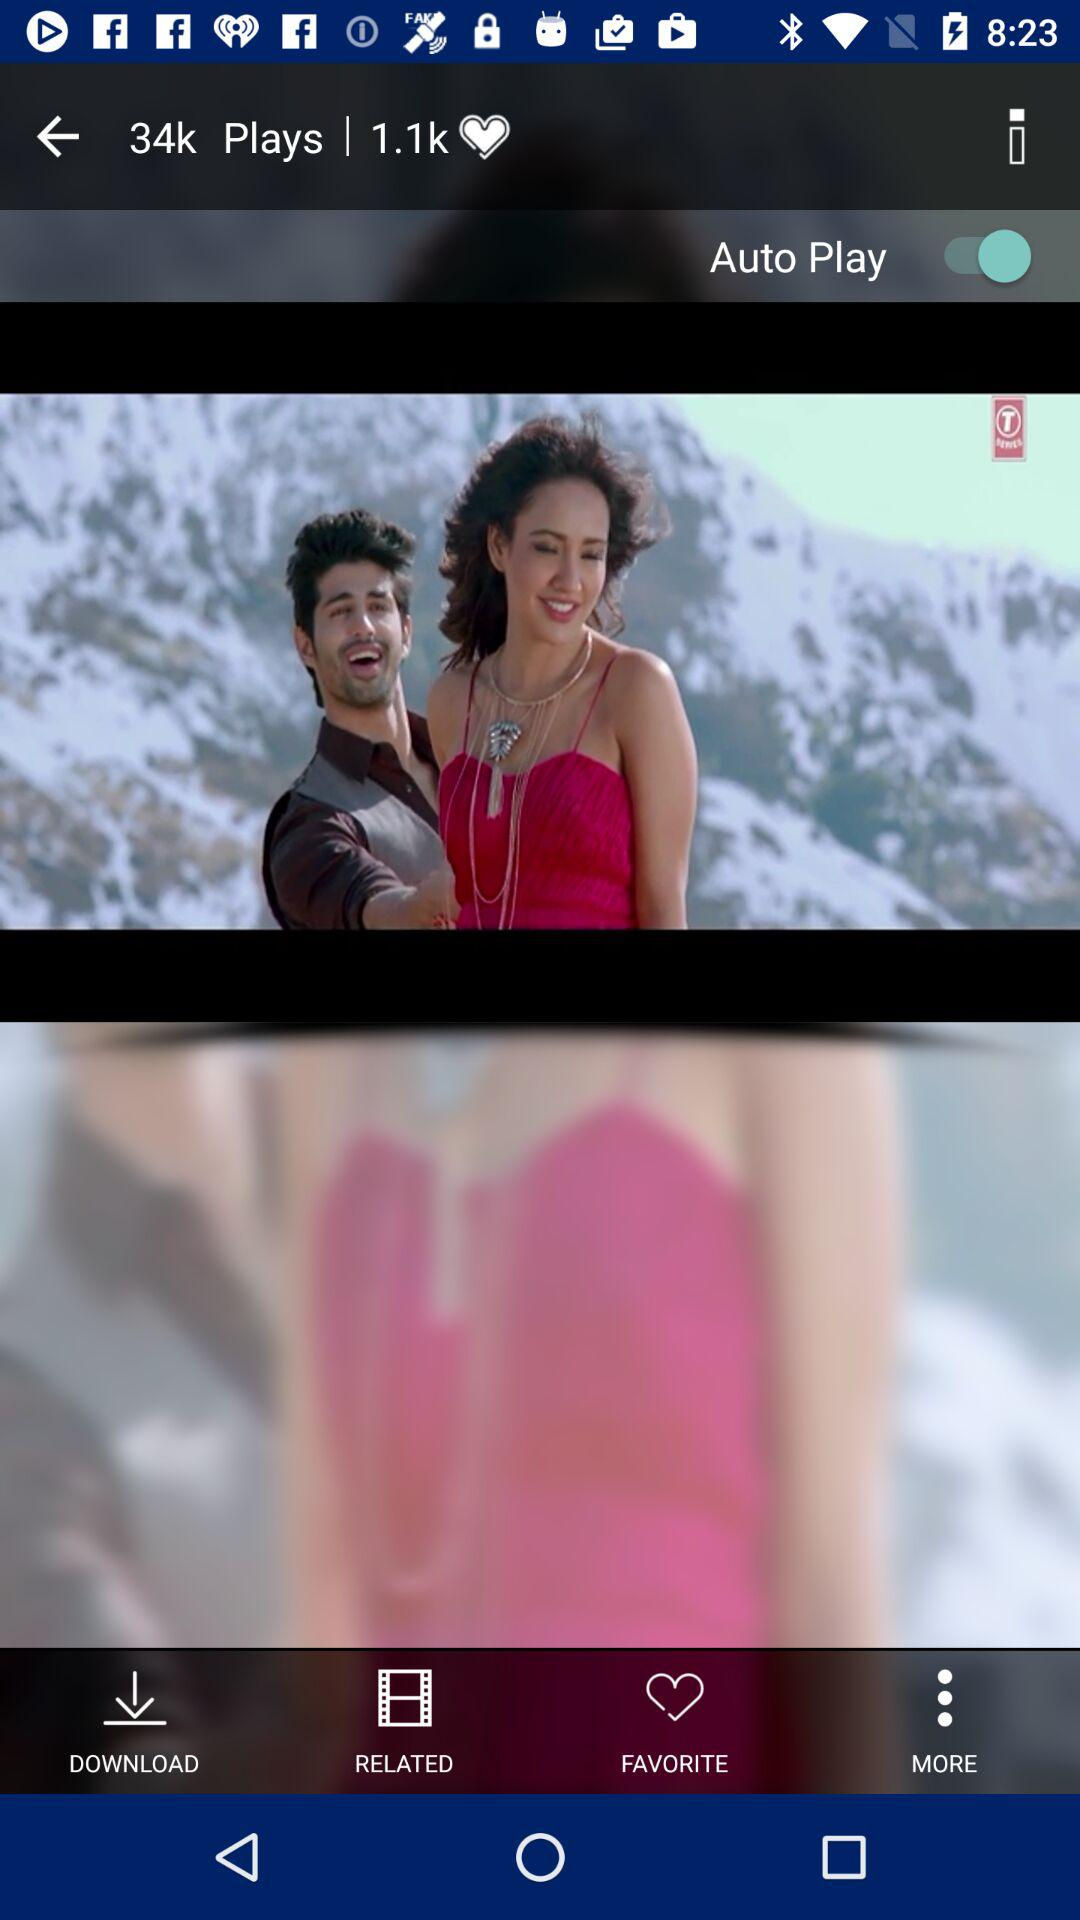What is the status of the "Auto Play"? The status of the "Auto Play" is "on". 